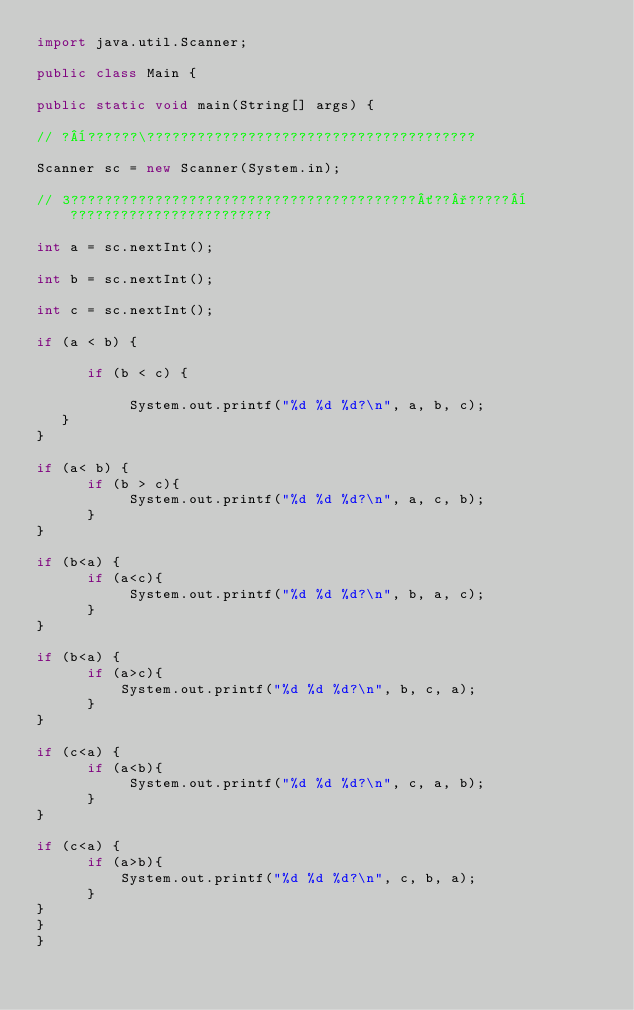<code> <loc_0><loc_0><loc_500><loc_500><_Java_>import java.util.Scanner;

public class Main {

public static void main(String[] args) {

// ?¨??????\???????????????????????????????????????

Scanner sc = new Scanner(System.in);

// 3?????????????????????????????????????????´??°?????¨????????????????????????

int a = sc.nextInt();

int b = sc.nextInt();

int c = sc.nextInt();

if (a < b) {

      if (b < c) {

           System.out.printf("%d %d %d?\n", a, b, c);
   }
}

if (a< b) {
      if (b > c){
           System.out.printf("%d %d %d?\n", a, c, b);
      }
}

if (b<a) {
      if (a<c){
           System.out.printf("%d %d %d?\n", b, a, c);
      }
}

if (b<a) {
      if (a>c){
          System.out.printf("%d %d %d?\n", b, c, a);
      }
}

if (c<a) {
      if (a<b){
           System.out.printf("%d %d %d?\n", c, a, b);
      }
}

if (c<a) {
      if (a>b){
          System.out.printf("%d %d %d?\n", c, b, a);
      }
}
}
}</code> 